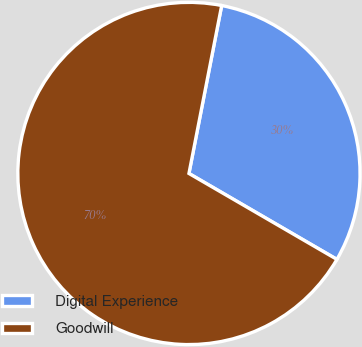Convert chart to OTSL. <chart><loc_0><loc_0><loc_500><loc_500><pie_chart><fcel>Digital Experience<fcel>Goodwill<nl><fcel>30.31%<fcel>69.69%<nl></chart> 